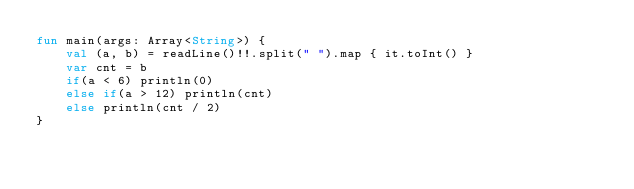Convert code to text. <code><loc_0><loc_0><loc_500><loc_500><_Kotlin_>fun main(args: Array<String>) {
    val (a, b) = readLine()!!.split(" ").map { it.toInt() }
    var cnt = b
    if(a < 6) println(0)
    else if(a > 12) println(cnt)
    else println(cnt / 2)
}</code> 